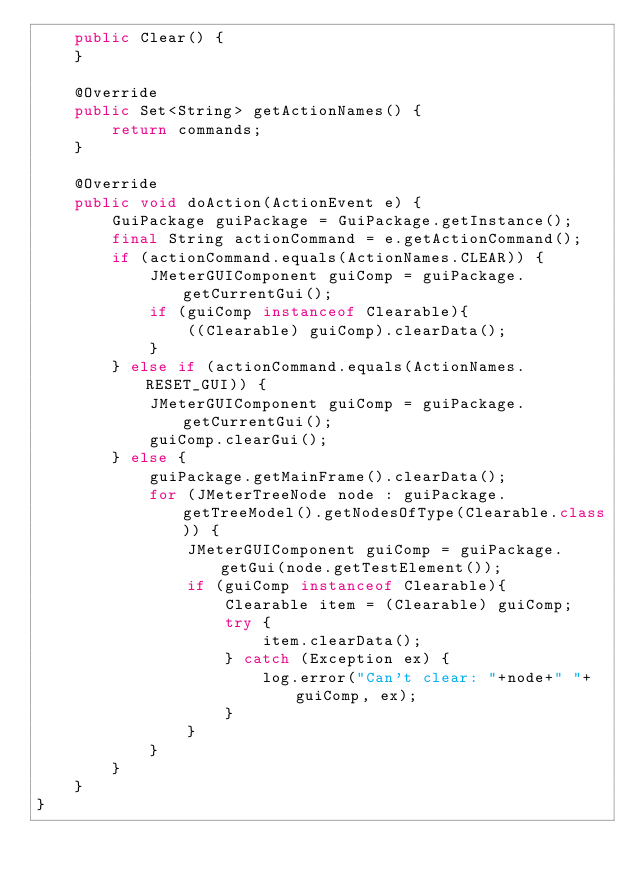Convert code to text. <code><loc_0><loc_0><loc_500><loc_500><_Java_>    public Clear() {
    }

    @Override
    public Set<String> getActionNames() {
        return commands;
    }

    @Override
    public void doAction(ActionEvent e) {
        GuiPackage guiPackage = GuiPackage.getInstance();
        final String actionCommand = e.getActionCommand();
        if (actionCommand.equals(ActionNames.CLEAR)) {
            JMeterGUIComponent guiComp = guiPackage.getCurrentGui();
            if (guiComp instanceof Clearable){
                ((Clearable) guiComp).clearData();
            }
        } else if (actionCommand.equals(ActionNames.RESET_GUI)) {
            JMeterGUIComponent guiComp = guiPackage.getCurrentGui();
            guiComp.clearGui();
        } else {
            guiPackage.getMainFrame().clearData();
            for (JMeterTreeNode node : guiPackage.getTreeModel().getNodesOfType(Clearable.class)) {
                JMeterGUIComponent guiComp = guiPackage.getGui(node.getTestElement());
                if (guiComp instanceof Clearable){
                    Clearable item = (Clearable) guiComp;
                    try {
                        item.clearData();
                    } catch (Exception ex) {
                        log.error("Can't clear: "+node+" "+guiComp, ex);
                    }
                }
            }
        }
    }
}
</code> 